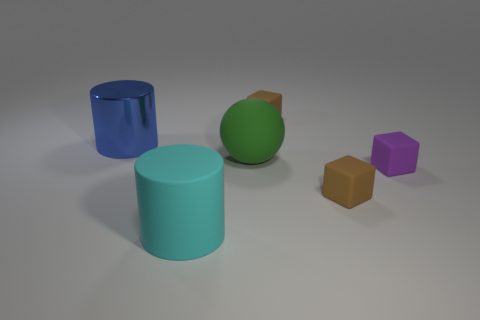Is the size of the cyan cylinder the same as the purple rubber cube?
Your answer should be very brief. No. What number of other objects are there of the same size as the purple matte object?
Ensure brevity in your answer.  2. What number of things are matte objects that are in front of the shiny cylinder or matte things behind the blue shiny cylinder?
Provide a succinct answer. 5. The other matte thing that is the same size as the cyan matte object is what shape?
Your response must be concise. Sphere. The cyan cylinder that is made of the same material as the large green object is what size?
Provide a short and direct response. Large. Is the shape of the large green matte object the same as the cyan matte thing?
Your response must be concise. No. There is a matte ball that is the same size as the cyan matte object; what is its color?
Keep it short and to the point. Green. What is the size of the blue thing that is the same shape as the cyan thing?
Offer a terse response. Large. What is the shape of the big thing that is to the right of the large cyan thing?
Your response must be concise. Sphere. Do the large cyan thing and the small thing in front of the purple rubber object have the same shape?
Make the answer very short. No. 